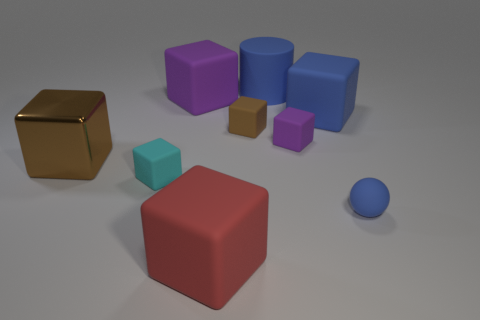Is the size of the purple matte cube on the left side of the cylinder the same as the tiny purple matte block?
Offer a very short reply. No. What is the size of the metal object?
Your answer should be compact. Large. Are there any big metal objects of the same color as the cylinder?
Offer a terse response. No. What number of tiny objects are either red things or brown matte cubes?
Your answer should be very brief. 1. What size is the rubber object that is in front of the large shiny block and on the right side of the big blue matte cylinder?
Make the answer very short. Small. There is a big red rubber cube; what number of cylinders are behind it?
Provide a succinct answer. 1. There is a large rubber thing that is in front of the big purple cube and behind the big brown block; what shape is it?
Make the answer very short. Cube. There is a cube that is the same color as the shiny object; what is it made of?
Give a very brief answer. Rubber. How many blocks are cyan matte objects or large brown objects?
Your answer should be very brief. 2. There is a cylinder that is the same color as the tiny matte sphere; what is its size?
Make the answer very short. Large. 